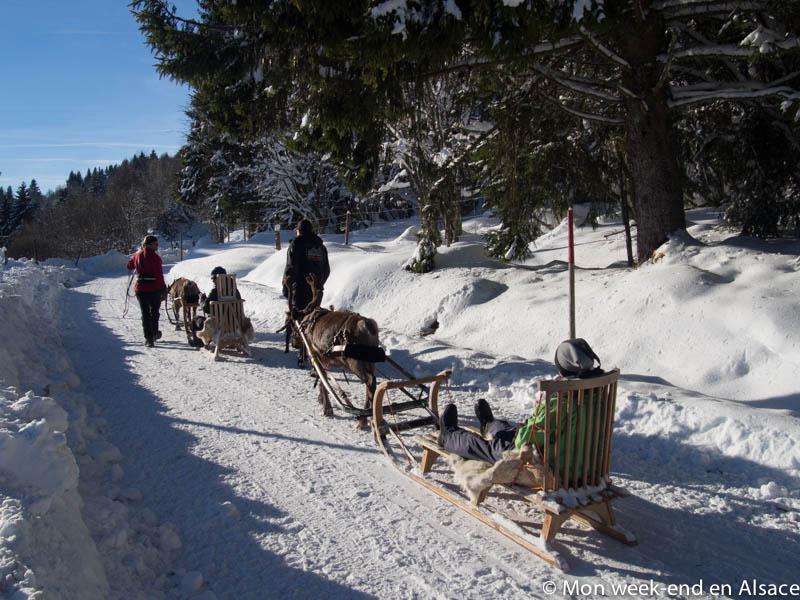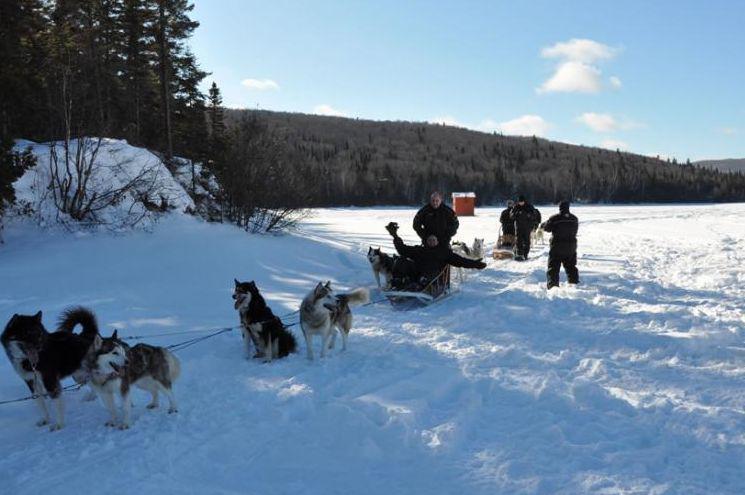The first image is the image on the left, the second image is the image on the right. Considering the images on both sides, is "There is at least one person wearing a red coat in the image on the right." valid? Answer yes or no. No. 